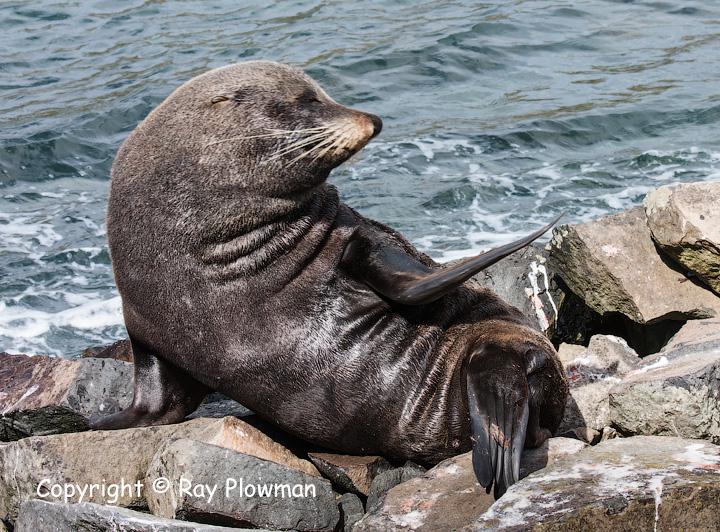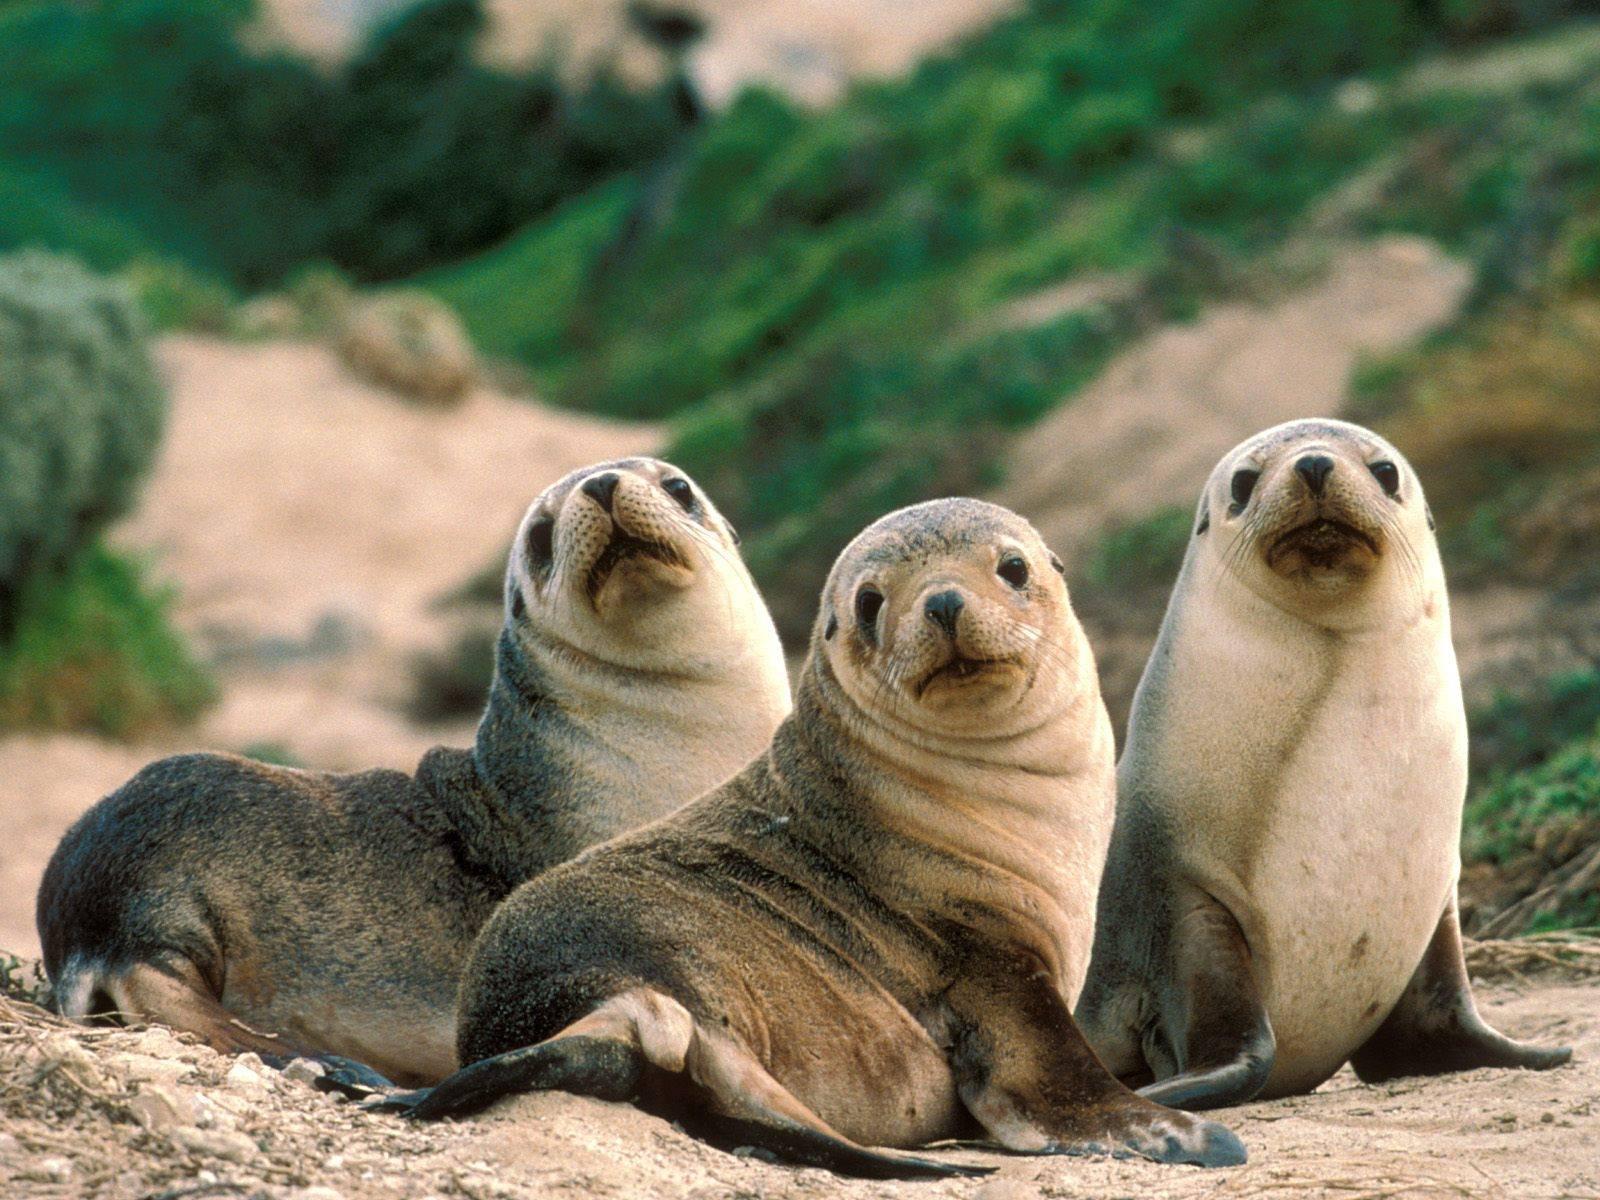The first image is the image on the left, the second image is the image on the right. Analyze the images presented: Is the assertion "The right image contains exactly two seals." valid? Answer yes or no. No. The first image is the image on the left, the second image is the image on the right. Assess this claim about the two images: "There are four sea lions in the image pair.". Correct or not? Answer yes or no. Yes. 